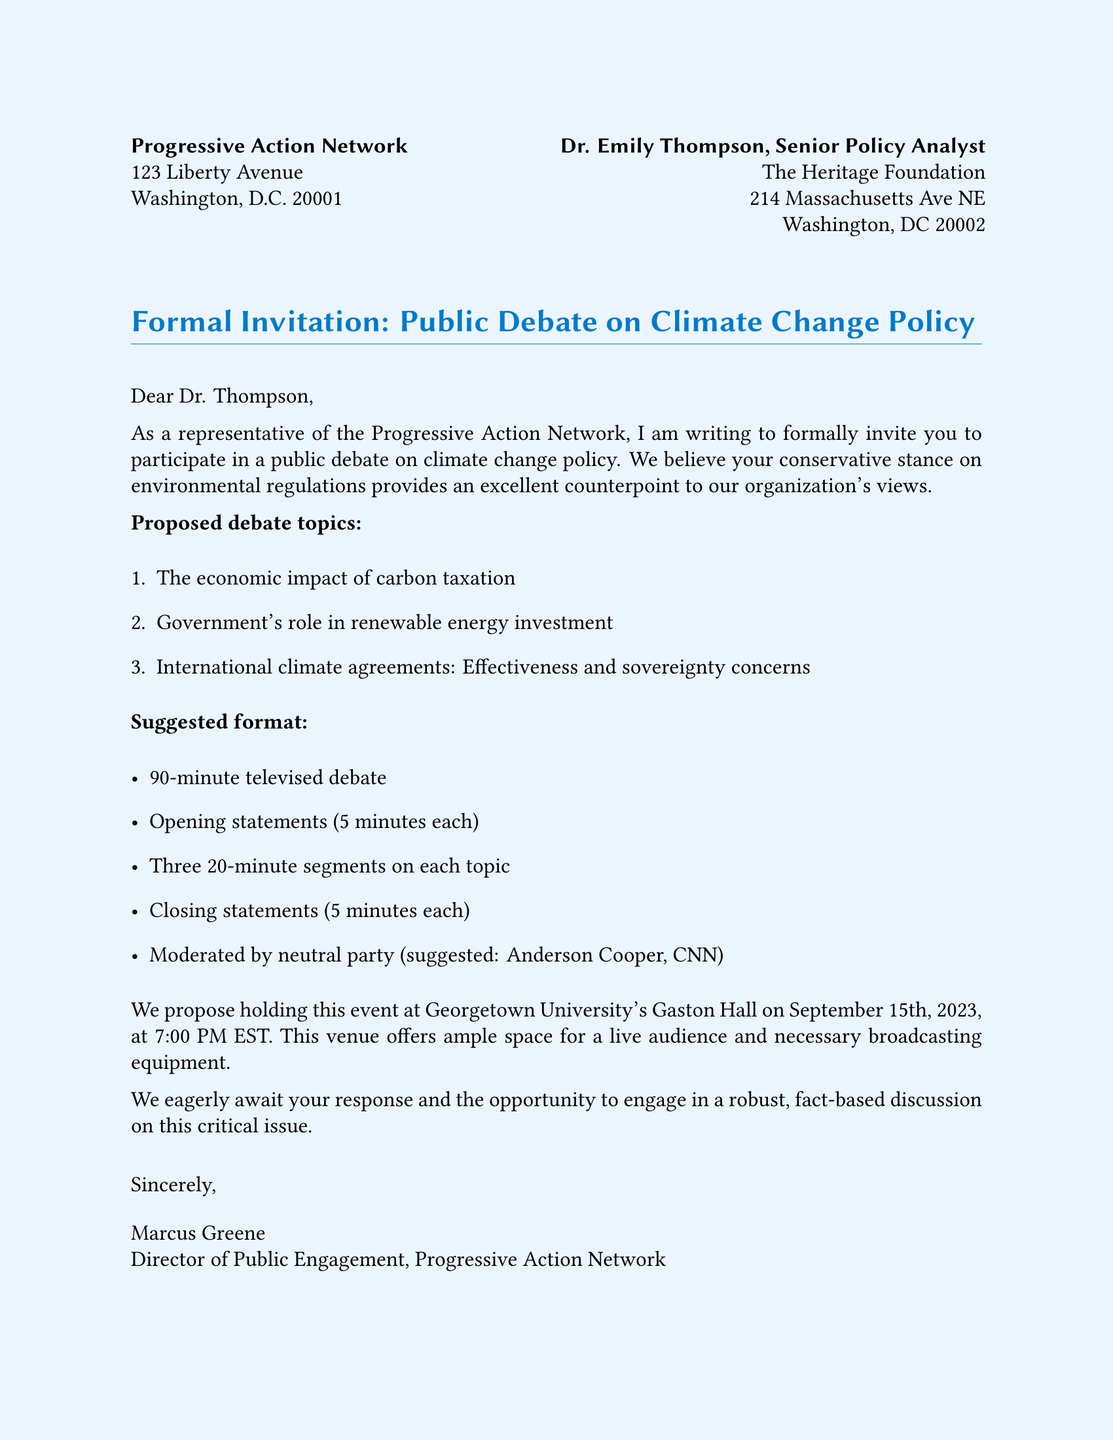What is the name of the organization sending the invitation? The name of the organization is mentioned at the top of the document, which is the Progressive Action Network.
Answer: Progressive Action Network Who is the recipient of the invitation? The recipient is identified by their title and organization, which is Dr. Emily Thompson from The Heritage Foundation.
Answer: Dr. Emily Thompson What is the proposed date and time for the debate event? The date and time for the debate event are specified in the document, which is September 15th, 2023, at 7:00 PM EST.
Answer: September 15th, 2023, at 7:00 PM EST How long is the opening statement for each participant? The document states that each participant has 5 minutes for their opening statement.
Answer: 5 minutes Who is suggested to moderate the debate? The moderator for the debate is suggested to be Anderson Cooper from CNN.
Answer: Anderson Cooper What is one proposed debate topic related to international agreements? The document includes a proposed topic regarding international climate agreements and its effectiveness and concerns about sovereignty.
Answer: International climate agreements: Effectiveness and sovereignty concerns How many segments are proposed for each debate topic? The document outlines that there will be three 20-minute segments on each topic.
Answer: Three What is the location for holding the debate event? The location mentioned in the document for the debate event is Georgetown University's Gaston Hall.
Answer: Georgetown University's Gaston Hall 